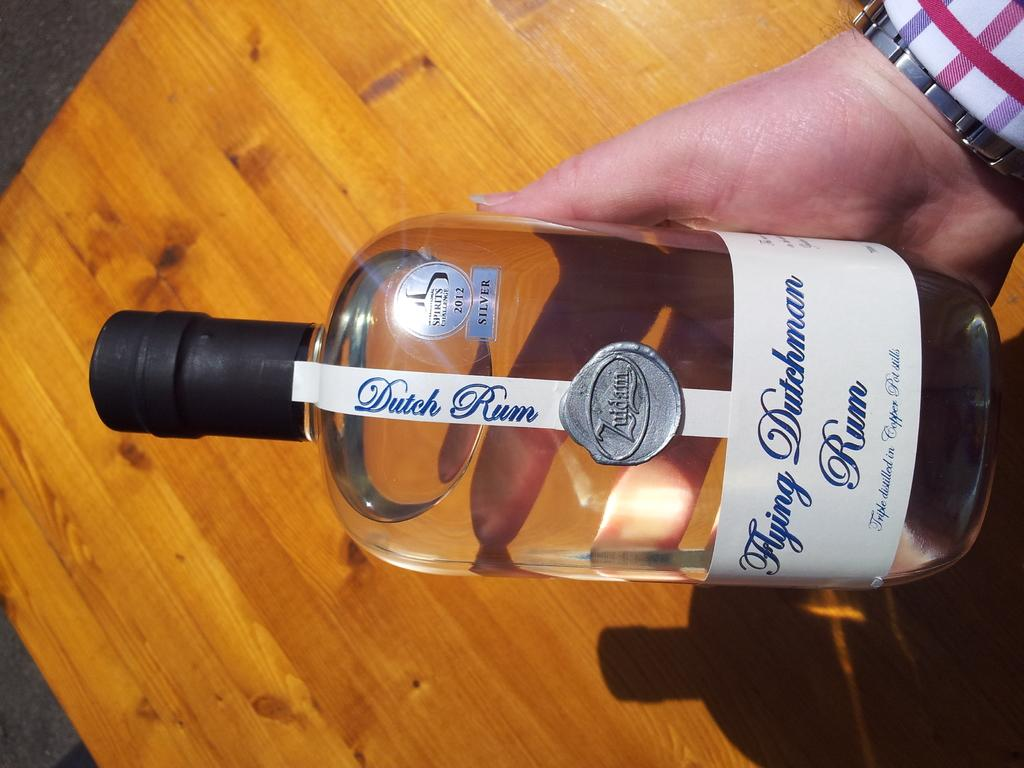What object is being held in the image? There is a bottle holder in the image, and it is being held with a hand. What can be seen on the bottle inside the holder? There is a white color sticker on the bottle. What type of surface is visible in the image? There is a table in the image. How many trucks are parked next to the table in the image? There are no trucks visible in the image; it only shows a bottle holder being held with a hand and a table. 